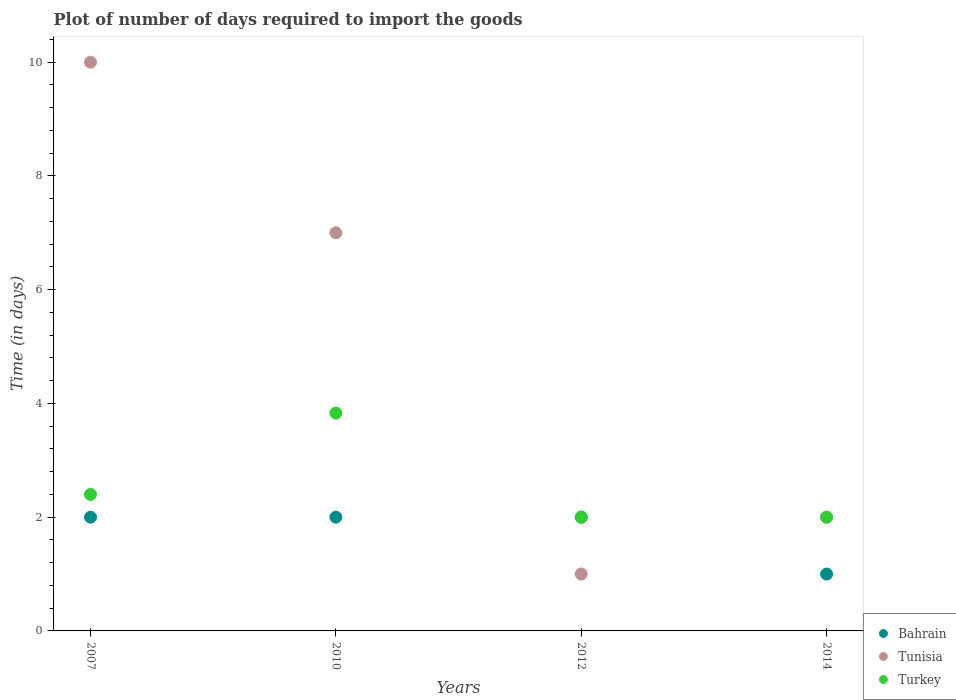How many different coloured dotlines are there?
Your answer should be compact. 3. What is the time required to import goods in Turkey in 2012?
Your answer should be compact. 2. Across all years, what is the maximum time required to import goods in Tunisia?
Give a very brief answer. 10. Across all years, what is the minimum time required to import goods in Tunisia?
Offer a terse response. 1. In which year was the time required to import goods in Turkey maximum?
Ensure brevity in your answer.  2010. In which year was the time required to import goods in Bahrain minimum?
Provide a short and direct response. 2014. What is the total time required to import goods in Bahrain in the graph?
Ensure brevity in your answer.  7. What is the difference between the time required to import goods in Turkey in 2007 and that in 2014?
Ensure brevity in your answer.  0.4. What is the difference between the time required to import goods in Bahrain in 2010 and the time required to import goods in Tunisia in 2007?
Your answer should be very brief. -8. What is the average time required to import goods in Turkey per year?
Give a very brief answer. 2.56. In the year 2007, what is the difference between the time required to import goods in Bahrain and time required to import goods in Tunisia?
Provide a short and direct response. -8. What is the ratio of the time required to import goods in Turkey in 2012 to that in 2014?
Provide a succinct answer. 1. What is the difference between the highest and the second highest time required to import goods in Turkey?
Ensure brevity in your answer.  1.43. What is the difference between the highest and the lowest time required to import goods in Bahrain?
Offer a terse response. 1. Is it the case that in every year, the sum of the time required to import goods in Turkey and time required to import goods in Bahrain  is greater than the time required to import goods in Tunisia?
Offer a very short reply. No. Does the time required to import goods in Bahrain monotonically increase over the years?
Your response must be concise. No. Is the time required to import goods in Turkey strictly less than the time required to import goods in Bahrain over the years?
Keep it short and to the point. No. What is the difference between two consecutive major ticks on the Y-axis?
Offer a terse response. 2. Are the values on the major ticks of Y-axis written in scientific E-notation?
Offer a terse response. No. How are the legend labels stacked?
Give a very brief answer. Vertical. What is the title of the graph?
Offer a terse response. Plot of number of days required to import the goods. Does "Thailand" appear as one of the legend labels in the graph?
Keep it short and to the point. No. What is the label or title of the X-axis?
Give a very brief answer. Years. What is the label or title of the Y-axis?
Keep it short and to the point. Time (in days). What is the Time (in days) of Bahrain in 2010?
Ensure brevity in your answer.  2. What is the Time (in days) of Turkey in 2010?
Keep it short and to the point. 3.83. What is the Time (in days) of Tunisia in 2012?
Give a very brief answer. 1. What is the Time (in days) in Turkey in 2012?
Provide a short and direct response. 2. What is the Time (in days) of Bahrain in 2014?
Your answer should be compact. 1. What is the Time (in days) of Tunisia in 2014?
Your response must be concise. 2. What is the Time (in days) in Turkey in 2014?
Offer a very short reply. 2. Across all years, what is the maximum Time (in days) of Tunisia?
Give a very brief answer. 10. Across all years, what is the maximum Time (in days) of Turkey?
Your response must be concise. 3.83. What is the total Time (in days) in Tunisia in the graph?
Keep it short and to the point. 20. What is the total Time (in days) in Turkey in the graph?
Keep it short and to the point. 10.23. What is the difference between the Time (in days) of Bahrain in 2007 and that in 2010?
Ensure brevity in your answer.  0. What is the difference between the Time (in days) in Tunisia in 2007 and that in 2010?
Your response must be concise. 3. What is the difference between the Time (in days) of Turkey in 2007 and that in 2010?
Offer a terse response. -1.43. What is the difference between the Time (in days) of Bahrain in 2007 and that in 2014?
Ensure brevity in your answer.  1. What is the difference between the Time (in days) in Turkey in 2010 and that in 2012?
Your answer should be very brief. 1.83. What is the difference between the Time (in days) of Turkey in 2010 and that in 2014?
Your response must be concise. 1.83. What is the difference between the Time (in days) in Bahrain in 2012 and that in 2014?
Give a very brief answer. 1. What is the difference between the Time (in days) of Bahrain in 2007 and the Time (in days) of Tunisia in 2010?
Ensure brevity in your answer.  -5. What is the difference between the Time (in days) in Bahrain in 2007 and the Time (in days) in Turkey in 2010?
Offer a terse response. -1.83. What is the difference between the Time (in days) in Tunisia in 2007 and the Time (in days) in Turkey in 2010?
Offer a terse response. 6.17. What is the difference between the Time (in days) of Bahrain in 2010 and the Time (in days) of Turkey in 2012?
Your response must be concise. 0. What is the difference between the Time (in days) in Bahrain in 2010 and the Time (in days) in Tunisia in 2014?
Your answer should be compact. 0. What is the difference between the Time (in days) in Bahrain in 2010 and the Time (in days) in Turkey in 2014?
Provide a short and direct response. 0. What is the difference between the Time (in days) in Tunisia in 2010 and the Time (in days) in Turkey in 2014?
Provide a short and direct response. 5. What is the difference between the Time (in days) in Bahrain in 2012 and the Time (in days) in Turkey in 2014?
Provide a short and direct response. 0. What is the difference between the Time (in days) of Tunisia in 2012 and the Time (in days) of Turkey in 2014?
Provide a succinct answer. -1. What is the average Time (in days) of Bahrain per year?
Offer a very short reply. 1.75. What is the average Time (in days) of Tunisia per year?
Offer a terse response. 5. What is the average Time (in days) of Turkey per year?
Your response must be concise. 2.56. In the year 2007, what is the difference between the Time (in days) in Bahrain and Time (in days) in Tunisia?
Offer a terse response. -8. In the year 2010, what is the difference between the Time (in days) in Bahrain and Time (in days) in Tunisia?
Make the answer very short. -5. In the year 2010, what is the difference between the Time (in days) of Bahrain and Time (in days) of Turkey?
Provide a short and direct response. -1.83. In the year 2010, what is the difference between the Time (in days) in Tunisia and Time (in days) in Turkey?
Your response must be concise. 3.17. In the year 2012, what is the difference between the Time (in days) of Tunisia and Time (in days) of Turkey?
Provide a short and direct response. -1. In the year 2014, what is the difference between the Time (in days) in Bahrain and Time (in days) in Tunisia?
Your response must be concise. -1. In the year 2014, what is the difference between the Time (in days) of Bahrain and Time (in days) of Turkey?
Offer a terse response. -1. In the year 2014, what is the difference between the Time (in days) in Tunisia and Time (in days) in Turkey?
Offer a very short reply. 0. What is the ratio of the Time (in days) in Tunisia in 2007 to that in 2010?
Provide a succinct answer. 1.43. What is the ratio of the Time (in days) in Turkey in 2007 to that in 2010?
Make the answer very short. 0.63. What is the ratio of the Time (in days) in Turkey in 2007 to that in 2014?
Keep it short and to the point. 1.2. What is the ratio of the Time (in days) of Turkey in 2010 to that in 2012?
Offer a terse response. 1.92. What is the ratio of the Time (in days) in Bahrain in 2010 to that in 2014?
Your response must be concise. 2. What is the ratio of the Time (in days) of Tunisia in 2010 to that in 2014?
Give a very brief answer. 3.5. What is the ratio of the Time (in days) of Turkey in 2010 to that in 2014?
Your answer should be very brief. 1.92. What is the difference between the highest and the second highest Time (in days) of Tunisia?
Give a very brief answer. 3. What is the difference between the highest and the second highest Time (in days) of Turkey?
Provide a succinct answer. 1.43. What is the difference between the highest and the lowest Time (in days) of Tunisia?
Keep it short and to the point. 9. What is the difference between the highest and the lowest Time (in days) of Turkey?
Your response must be concise. 1.83. 